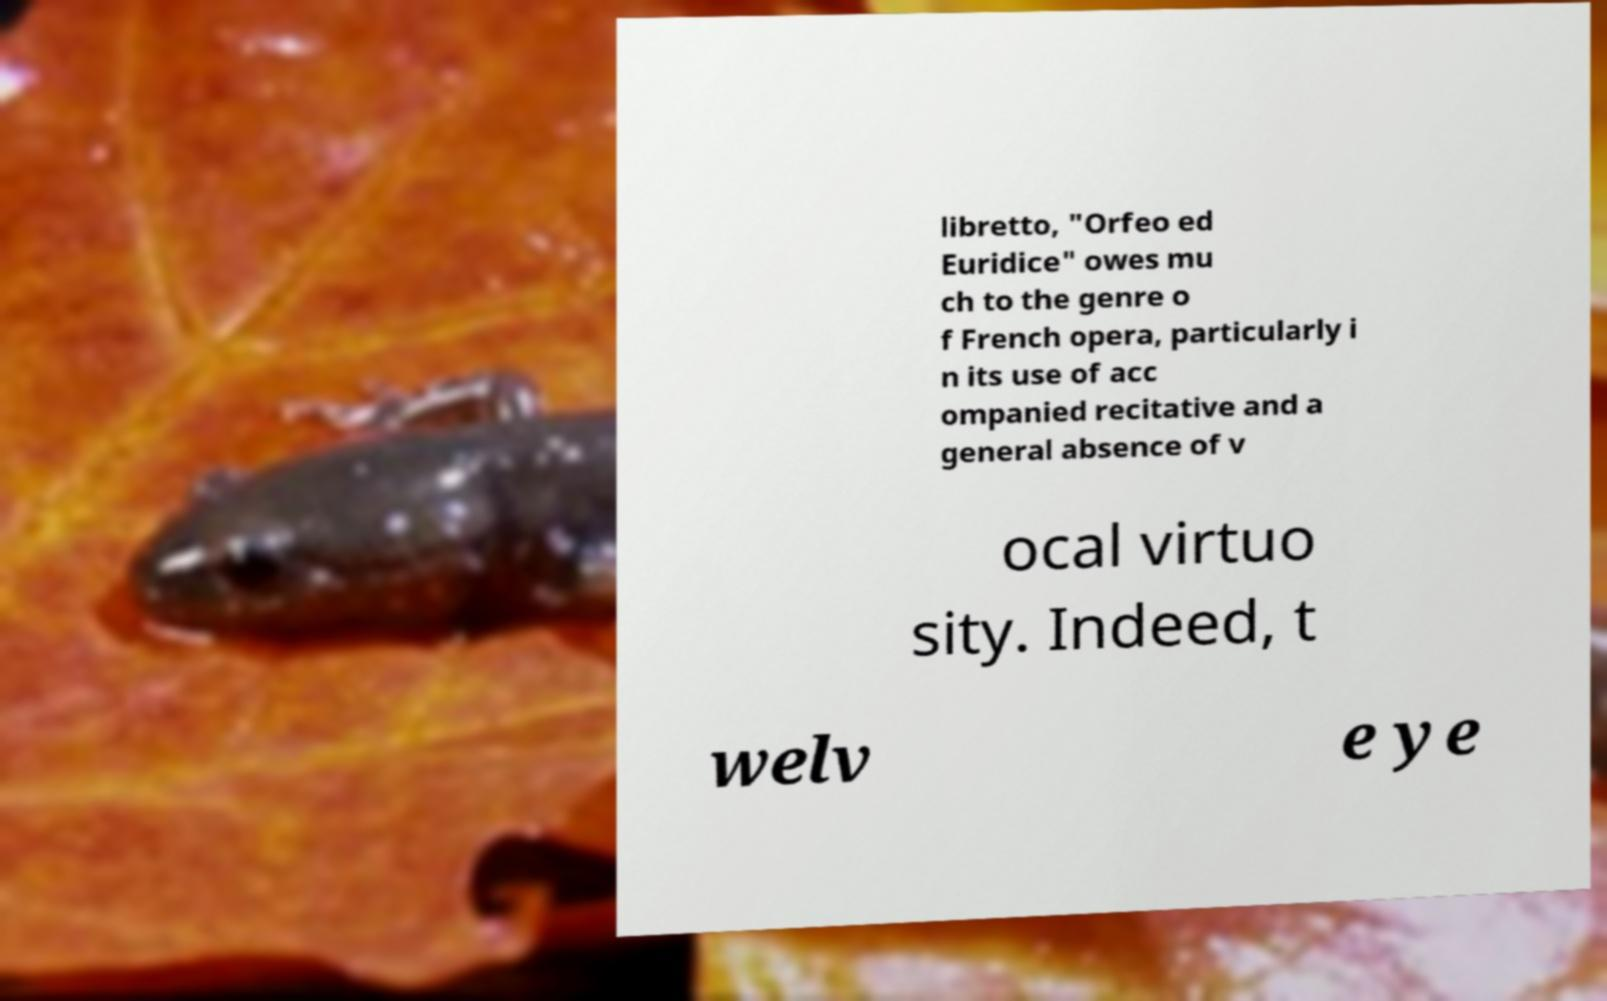Please identify and transcribe the text found in this image. libretto, "Orfeo ed Euridice" owes mu ch to the genre o f French opera, particularly i n its use of acc ompanied recitative and a general absence of v ocal virtuo sity. Indeed, t welv e ye 